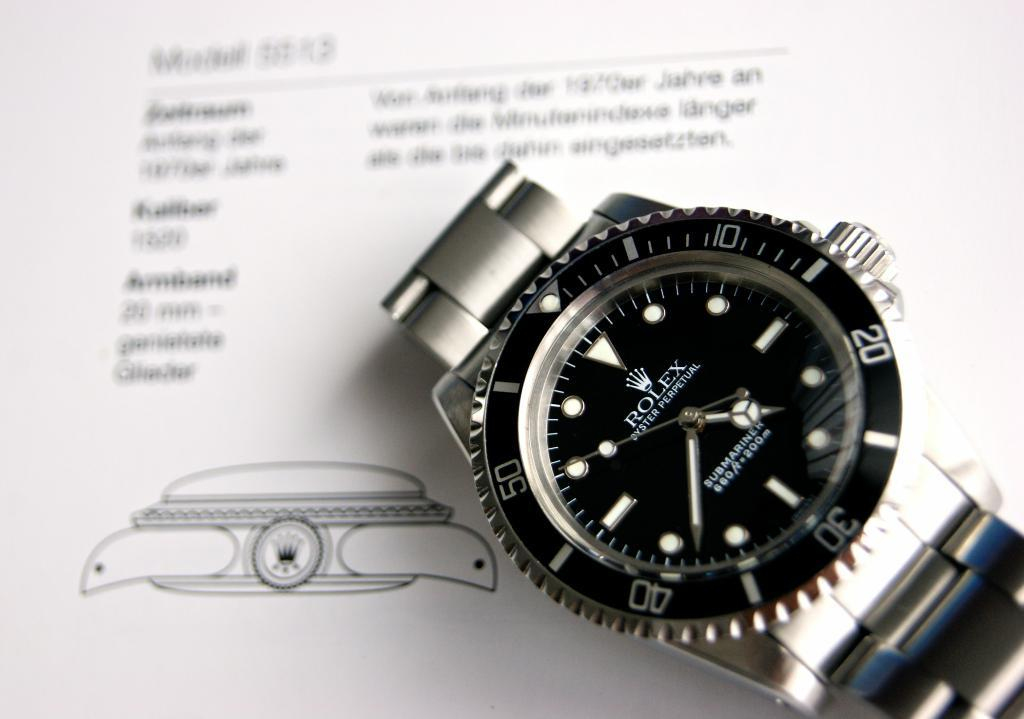<image>
Summarize the visual content of the image. A Rolex watch that is a submariner up to 660 feet. 